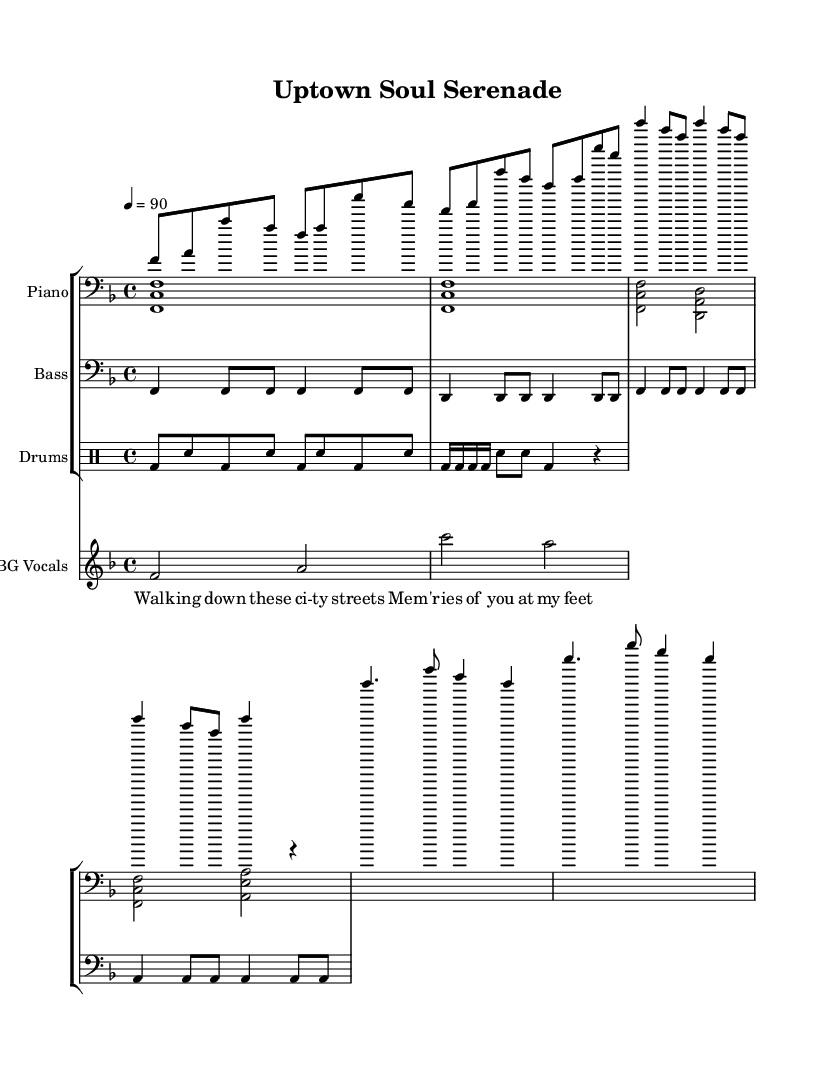What is the key signature of this music? The key signature is F major, which has one flat (B flat). This can be determined by looking at the first part of the score where the key signature is displayed.
Answer: F major What is the time signature of this piece? The time signature shown is 4/4, indicating four beats in a measure and a quarter note receives one beat. This information is indicated at the beginning of the score.
Answer: 4/4 What is the tempo marking for this composition? The tempo is marked at 90 beats per minute, specified at the beginning of the score as "4 = 90". This informs performers of the speed at which to play.
Answer: 90 How many measures are in the verse? The verse contains four measures, which can be counted by observing the section of the score marked with the lyrics "Walking down these city streets". Each group of musical notation represents one measure.
Answer: 4 What type of accompaniment is primarily used in this piece? The accompaniment is primarily piano-driven, shown by the presence of two piano staves for the right and left hands. This utilizes the piano as the main instrument for melody and harmony.
Answer: Piano-driven What scale is primarily used in the melody? The melody predominantly uses notes from the F major scale, as indicated by the key signature and the notes played throughout the score. To confirm, one can analyze the pitches used in the melody lines.
Answer: F major Identify the vocal part type in this score. The vocal part consists of background vocals indicated in the choir staff, featuring harmonies that complement the main melody. This is evident from the separate staff labeled "BG Vocals".
Answer: Background vocals 